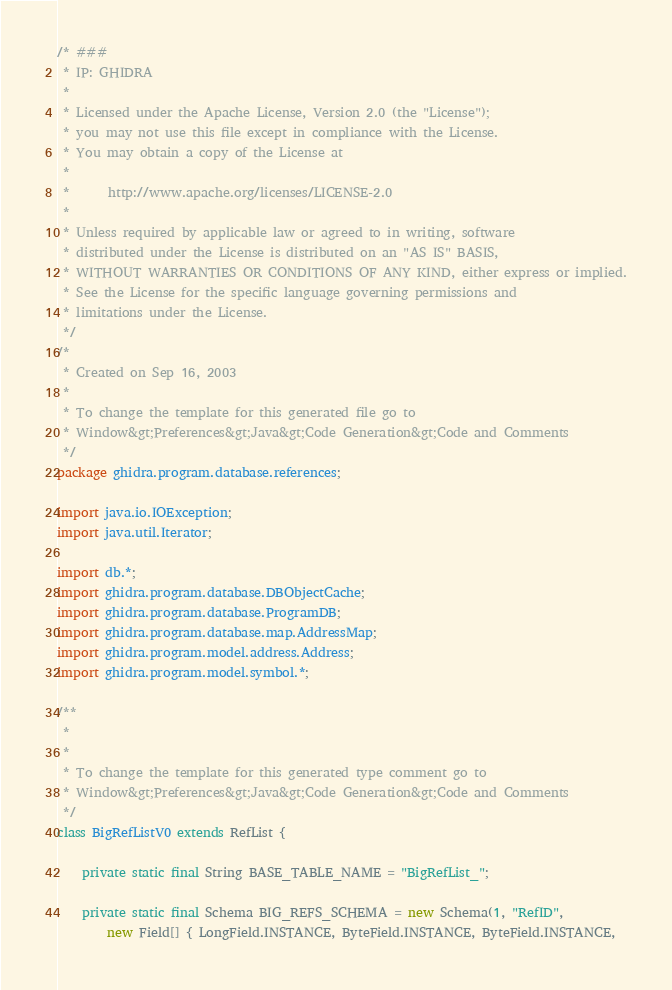<code> <loc_0><loc_0><loc_500><loc_500><_Java_>/* ###
 * IP: GHIDRA
 *
 * Licensed under the Apache License, Version 2.0 (the "License");
 * you may not use this file except in compliance with the License.
 * You may obtain a copy of the License at
 * 
 *      http://www.apache.org/licenses/LICENSE-2.0
 * 
 * Unless required by applicable law or agreed to in writing, software
 * distributed under the License is distributed on an "AS IS" BASIS,
 * WITHOUT WARRANTIES OR CONDITIONS OF ANY KIND, either express or implied.
 * See the License for the specific language governing permissions and
 * limitations under the License.
 */
/*
 * Created on Sep 16, 2003
 *
 * To change the template for this generated file go to
 * Window&gt;Preferences&gt;Java&gt;Code Generation&gt;Code and Comments
 */
package ghidra.program.database.references;

import java.io.IOException;
import java.util.Iterator;

import db.*;
import ghidra.program.database.DBObjectCache;
import ghidra.program.database.ProgramDB;
import ghidra.program.database.map.AddressMap;
import ghidra.program.model.address.Address;
import ghidra.program.model.symbol.*;

/**
 * 
 *
 * To change the template for this generated type comment go to
 * Window&gt;Preferences&gt;Java&gt;Code Generation&gt;Code and Comments
 */
class BigRefListV0 extends RefList {

	private static final String BASE_TABLE_NAME = "BigRefList_";

	private static final Schema BIG_REFS_SCHEMA = new Schema(1, "RefID",
		new Field[] { LongField.INSTANCE, ByteField.INSTANCE, ByteField.INSTANCE,</code> 